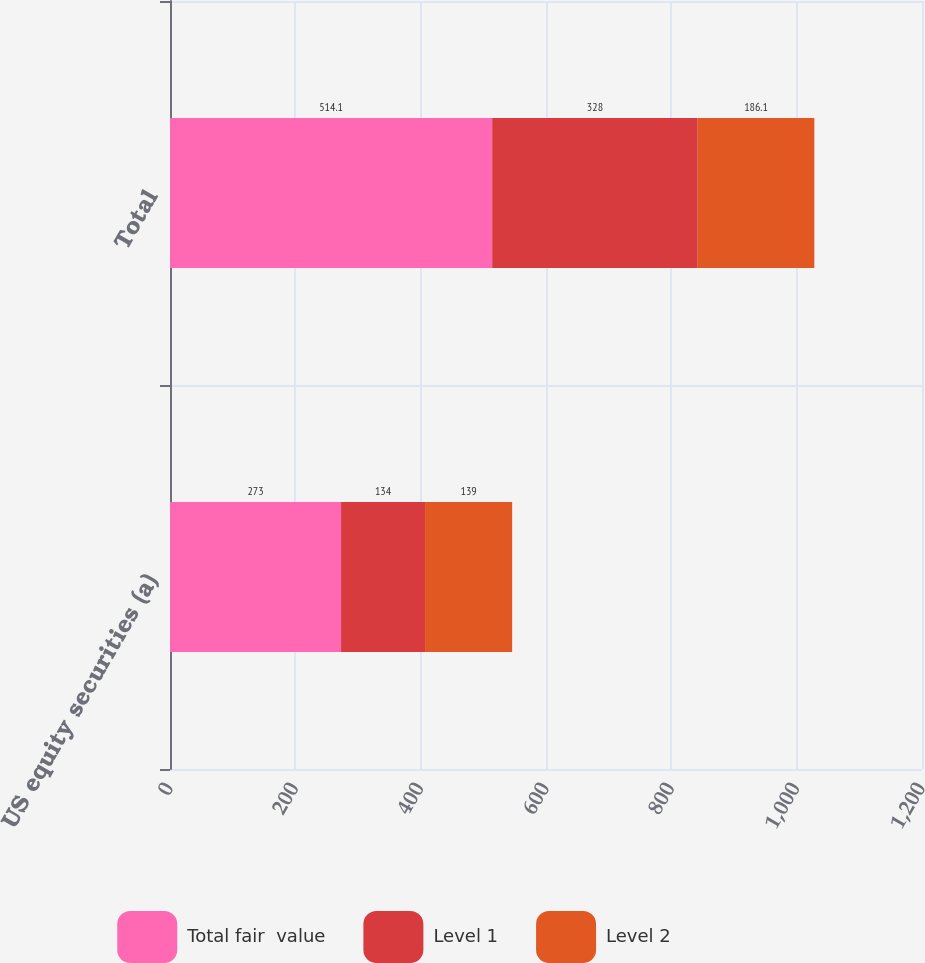Convert chart to OTSL. <chart><loc_0><loc_0><loc_500><loc_500><stacked_bar_chart><ecel><fcel>US equity securities (a)<fcel>Total<nl><fcel>Total fair  value<fcel>273<fcel>514.1<nl><fcel>Level 1<fcel>134<fcel>328<nl><fcel>Level 2<fcel>139<fcel>186.1<nl></chart> 